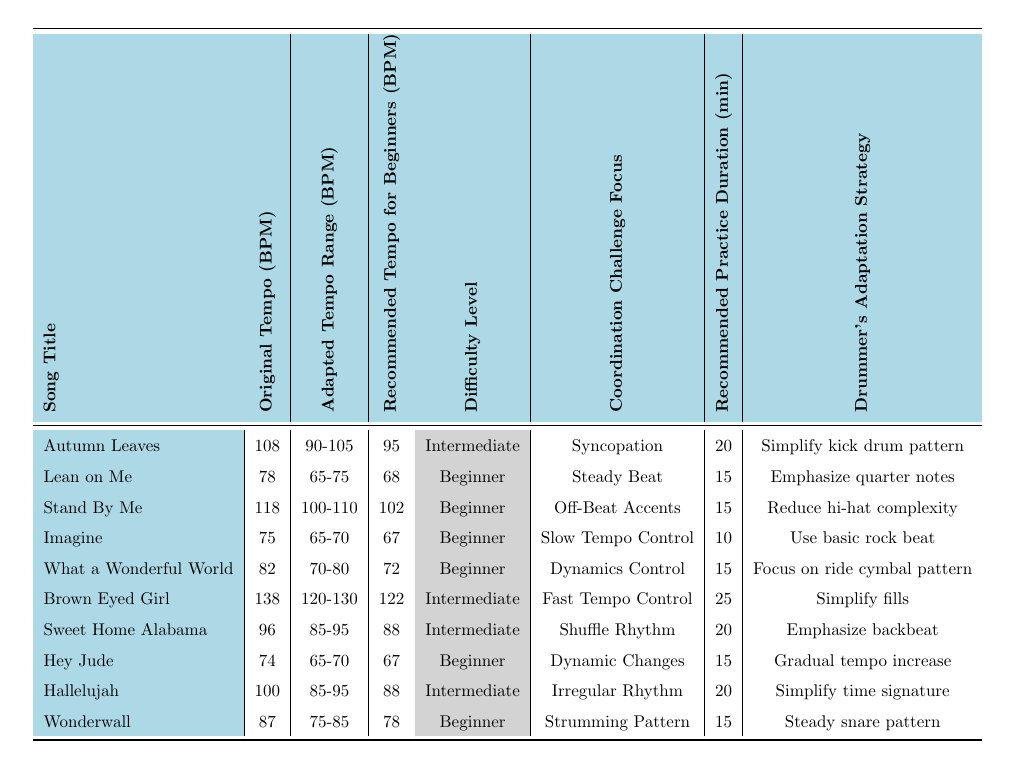What is the recommended tempo for beginners for "Imagine"? The recommended tempo for beginners for "Imagine" can be found in the table under the "Recommended Tempo for Beginners (BPM)" column. It shows a value of 67 BPM for this song.
Answer: 67 What is the difficulty level of "Stand By Me"? The difficulty level for "Stand By Me" is listed in the "Difficulty Level" column of the table. It is categorized as "Beginner."
Answer: Beginner Which song has the highest original tempo? To find the highest original tempo, we look through the "Original Tempo (BPM)" column. The highest value is 138 BPM for "Brown Eyed Girl."
Answer: Brown Eyed Girl What is the average recommended practice duration for all songs? To calculate the average practice duration, sum the values in the "Recommended Practice Duration (minutes)" column (20 + 15 + 15 + 10 + 15 + 25 + 20 + 15 + 20 + 15 = 150) and divide by the number of songs (150 / 10 = 15).
Answer: 15 Is "Hallelujah" marked as an intermediate difficulty level? Checking the "Difficulty Level" column for "Hallelujah," it is categorized as "Intermediate," confirming it is marked as such.
Answer: Yes Which song has a coordination challenge focus on "Dynamics Control"? The "Coordination Challenge Focus" column indicates that "What a Wonderful World" specifically focuses on "Dynamics Control."
Answer: What a Wonderful World What is the recommended tempo range for "Lean on Me"? To find the recommended tempo range for "Lean on Me," we refer to the "Adapted Tempo Range (BPM)" column. It shows a range of 65-75 BPM.
Answer: 65-75 How does the recommended tempo for beginners compare between "Sweet Home Alabama" and "Wonderwall"? The recommended tempo for beginners for "Sweet Home Alabama" is 88 BPM, while for "Wonderwall," it is 78 BPM. Comparing these, "Sweet Home Alabama" has a higher tempo by 10 BPM.
Answer: Sweet Home Alabama is 10 BPM higher Which song requires the longest recommended practice duration? We compare the values in the "Recommended Practice Duration (minutes)" column. The longest duration is 25 minutes for "Brown Eyed Girl."
Answer: Brown Eyed Girl Is it true that all songs labeled as "Beginner" have an adapted tempo range that exceeds 75 BPM? Looking at the "Adapted Tempo Range (BPM)" column for all "Beginner" songs, we find "Lean on Me" with a range of 65-75 BPM, indicating it does not exceed 75 BPM.
Answer: No 